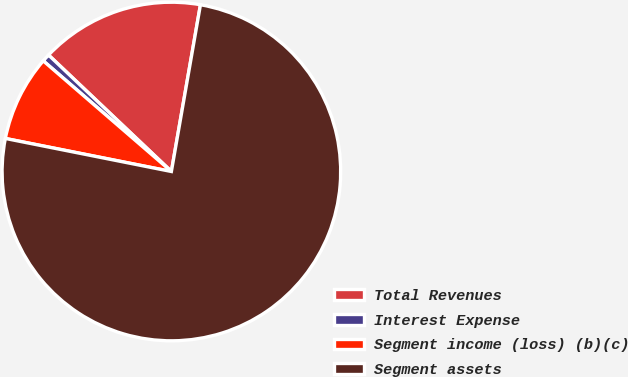Convert chart to OTSL. <chart><loc_0><loc_0><loc_500><loc_500><pie_chart><fcel>Total Revenues<fcel>Interest Expense<fcel>Segment income (loss) (b)(c)<fcel>Segment assets<nl><fcel>15.67%<fcel>0.74%<fcel>8.21%<fcel>75.38%<nl></chart> 